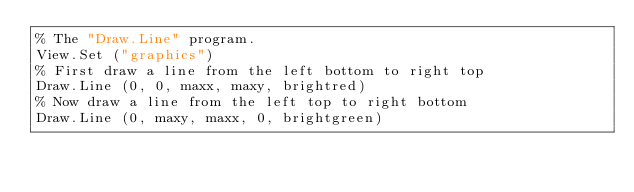Convert code to text. <code><loc_0><loc_0><loc_500><loc_500><_Perl_>% The "Draw.Line" program.
View.Set ("graphics")
% First draw a line from the left bottom to right top
Draw.Line (0, 0, maxx, maxy, brightred)
% Now draw a line from the left top to right bottom
Draw.Line (0, maxy, maxx, 0, brightgreen)
</code> 